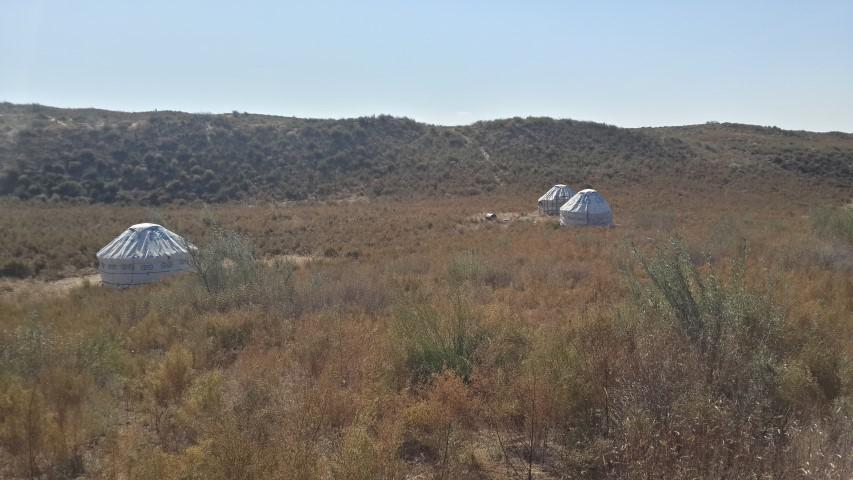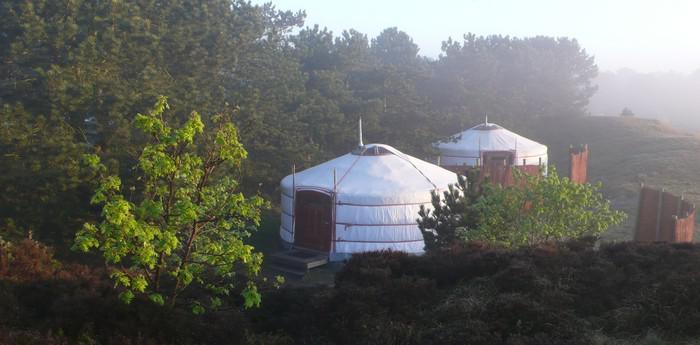The first image is the image on the left, the second image is the image on the right. For the images shown, is this caption "At least seven yurts of the same style are shown in a scrubby dessert setting in one image, while a second image shows at least 2 yurts." true? Answer yes or no. No. The first image is the image on the left, the second image is the image on the right. Considering the images on both sides, is "An image shows a group of round structures covered in brown material crossed with straps." valid? Answer yes or no. No. 